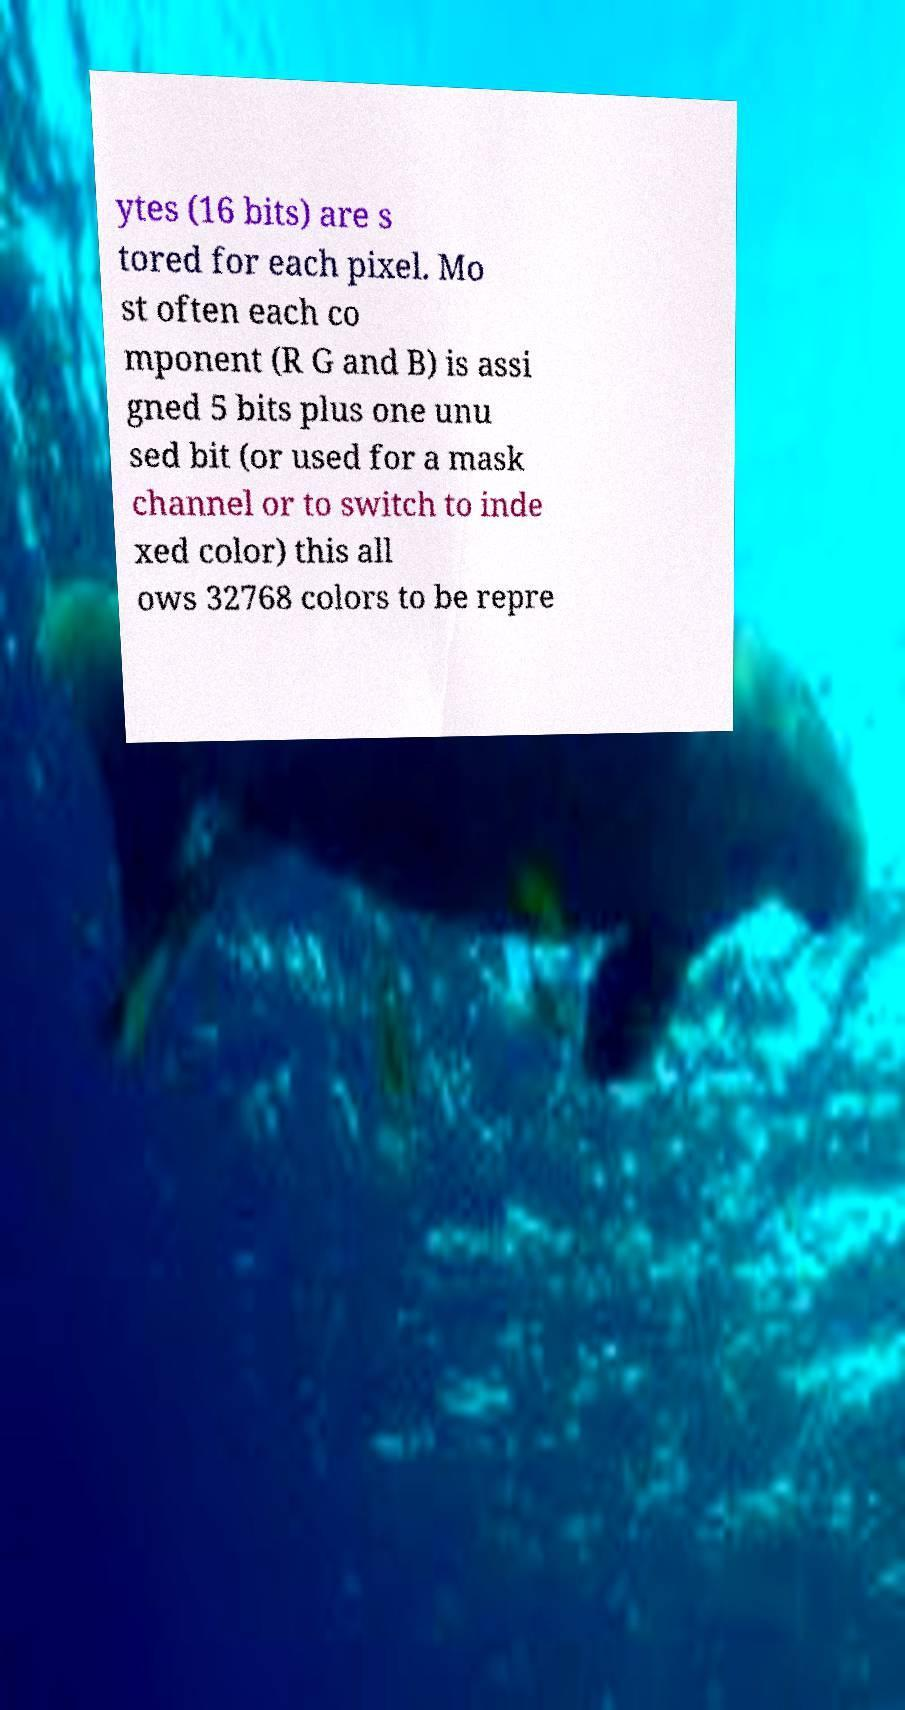I need the written content from this picture converted into text. Can you do that? ytes (16 bits) are s tored for each pixel. Mo st often each co mponent (R G and B) is assi gned 5 bits plus one unu sed bit (or used for a mask channel or to switch to inde xed color) this all ows 32768 colors to be repre 